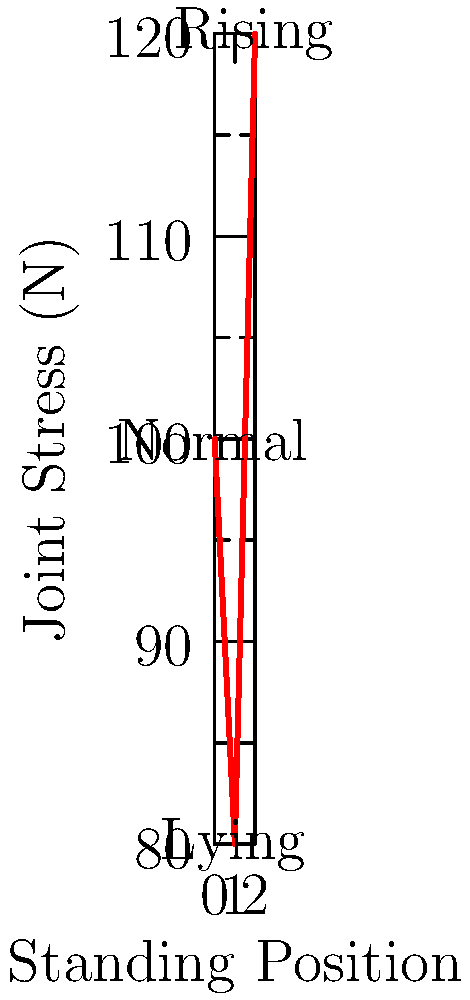Based on the graph showing joint stress in different standing positions for a cow, which position causes the highest biomechanical stress on the cow's joints, and by how much does it exceed the normal standing position? To answer this question, we need to analyze the graph and compare the joint stress values for different standing positions:

1. Normal standing position: 100 N
2. Lying position: 80 N
3. Rising position: 120 N

We can see that the rising position causes the highest biomechanical stress on the cow's joints at 120 N.

To calculate how much the rising position exceeds the normal standing position:

1. Difference = Rising position stress - Normal standing position stress
2. Difference = 120 N - 100 N = 20 N

Therefore, the rising position causes 20 N more stress than the normal standing position.

To express this as a percentage:
Percentage increase = (Difference / Normal standing stress) × 100%
Percentage increase = (20 N / 100 N) × 100% = 20%
Answer: Rising position; 20% higher than normal 